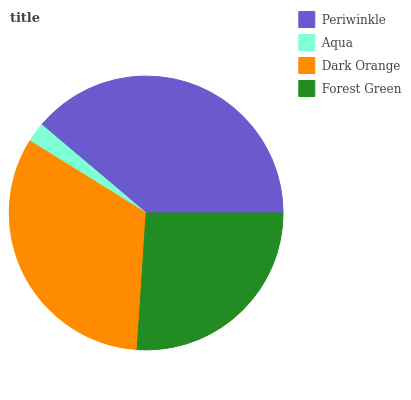Is Aqua the minimum?
Answer yes or no. Yes. Is Periwinkle the maximum?
Answer yes or no. Yes. Is Dark Orange the minimum?
Answer yes or no. No. Is Dark Orange the maximum?
Answer yes or no. No. Is Dark Orange greater than Aqua?
Answer yes or no. Yes. Is Aqua less than Dark Orange?
Answer yes or no. Yes. Is Aqua greater than Dark Orange?
Answer yes or no. No. Is Dark Orange less than Aqua?
Answer yes or no. No. Is Dark Orange the high median?
Answer yes or no. Yes. Is Forest Green the low median?
Answer yes or no. Yes. Is Aqua the high median?
Answer yes or no. No. Is Periwinkle the low median?
Answer yes or no. No. 